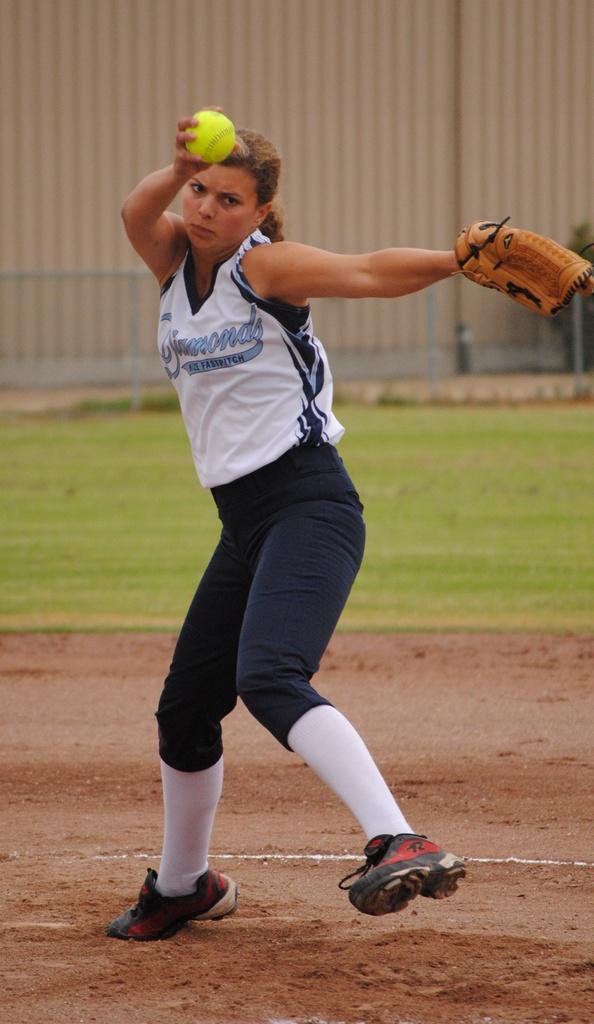What is the team name?
Give a very brief answer. Diamonds. 